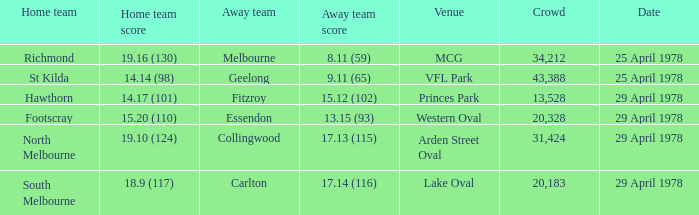In what venue was the hosted away team Essendon? Western Oval. 